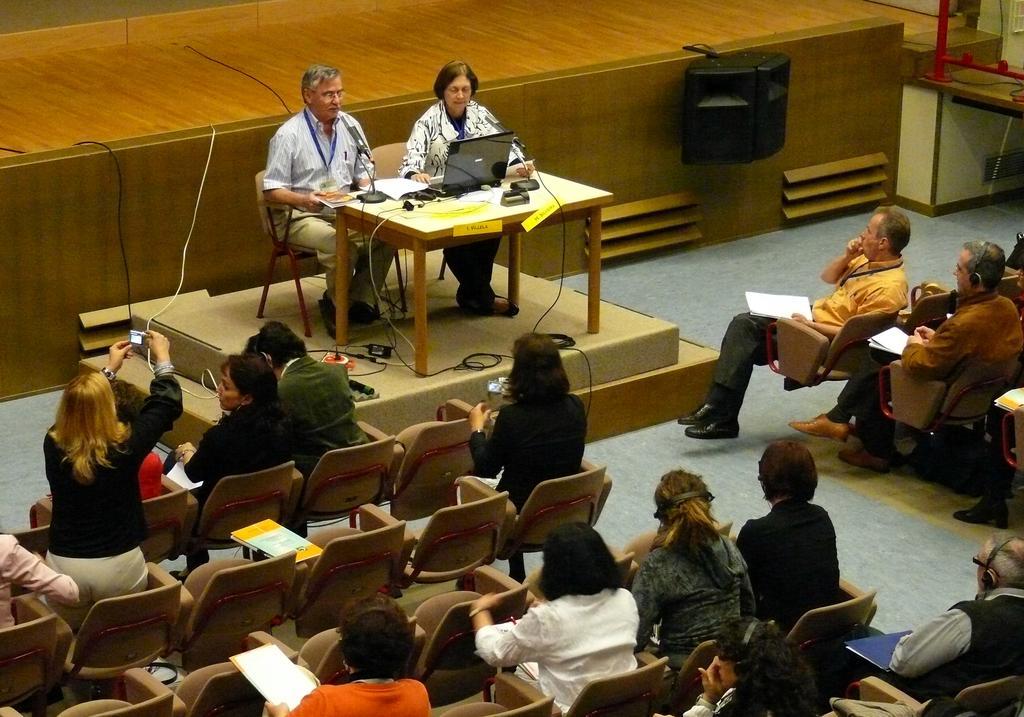How would you summarize this image in a sentence or two? In this image i can see a group of people sitting on chairs. I can see a table on which there is a laptop and microphone and few other objects. In the background i can see a speaker. 